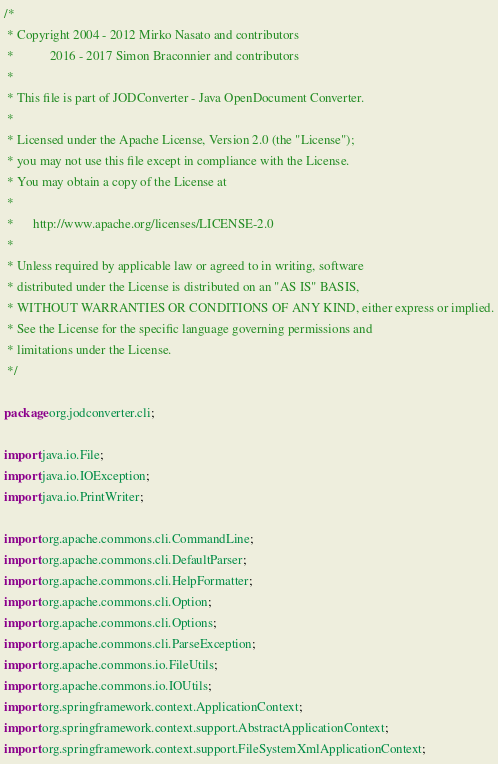<code> <loc_0><loc_0><loc_500><loc_500><_Java_>/*
 * Copyright 2004 - 2012 Mirko Nasato and contributors
 *           2016 - 2017 Simon Braconnier and contributors
 *
 * This file is part of JODConverter - Java OpenDocument Converter.
 *
 * Licensed under the Apache License, Version 2.0 (the "License");
 * you may not use this file except in compliance with the License.
 * You may obtain a copy of the License at
 *
 *      http://www.apache.org/licenses/LICENSE-2.0
 *
 * Unless required by applicable law or agreed to in writing, software
 * distributed under the License is distributed on an "AS IS" BASIS,
 * WITHOUT WARRANTIES OR CONDITIONS OF ANY KIND, either express or implied.
 * See the License for the specific language governing permissions and
 * limitations under the License.
 */

package org.jodconverter.cli;

import java.io.File;
import java.io.IOException;
import java.io.PrintWriter;

import org.apache.commons.cli.CommandLine;
import org.apache.commons.cli.DefaultParser;
import org.apache.commons.cli.HelpFormatter;
import org.apache.commons.cli.Option;
import org.apache.commons.cli.Options;
import org.apache.commons.cli.ParseException;
import org.apache.commons.io.FileUtils;
import org.apache.commons.io.IOUtils;
import org.springframework.context.ApplicationContext;
import org.springframework.context.support.AbstractApplicationContext;
import org.springframework.context.support.FileSystemXmlApplicationContext;
</code> 